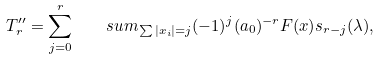<formula> <loc_0><loc_0><loc_500><loc_500>T ^ { \prime \prime } _ { r } = \sum _ { j = 0 } ^ { r } \quad s u m _ { \sum | x _ { i } | = j } ( - 1 ) ^ { j } ( a _ { 0 } ) ^ { - r } F ( x ) s _ { r - j } ( \lambda ) ,</formula> 